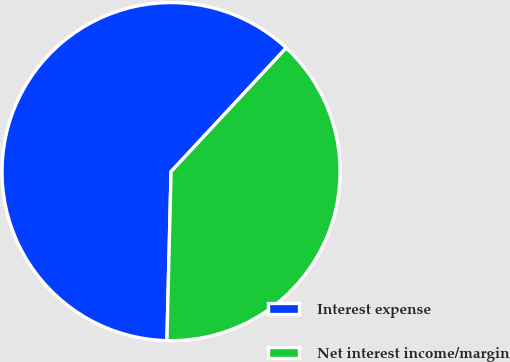<chart> <loc_0><loc_0><loc_500><loc_500><pie_chart><fcel>Interest expense<fcel>Net interest income/margin<nl><fcel>61.54%<fcel>38.46%<nl></chart> 